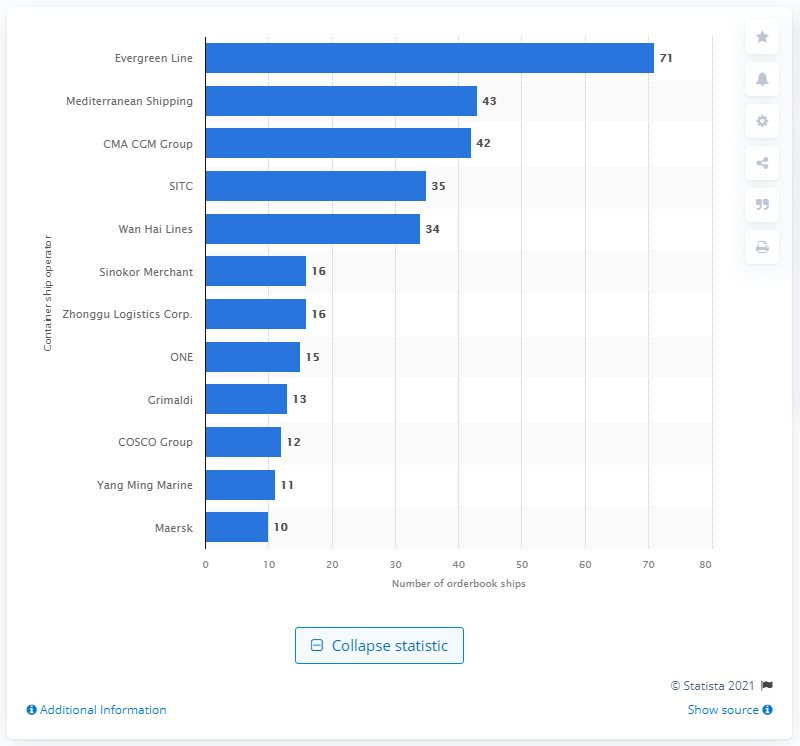How does CMA CGM Group's order book compare with Maersk according to the image? The image shows that CMA CGM Group has 42 ships in their order book, significantly more than Maersk, which has 10 ships. This indicates a larger scale of planned expansion for CMA CGM compared to Maersk. 